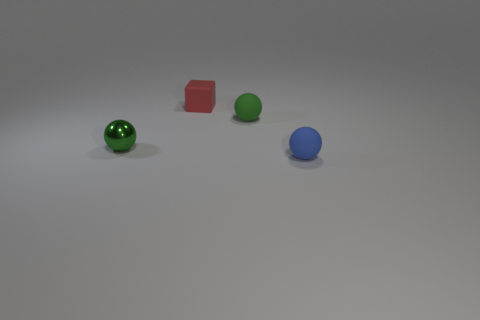Subtract all green balls. How many balls are left? 1 Add 2 big purple rubber things. How many objects exist? 6 Subtract all tiny matte spheres. How many spheres are left? 1 Add 1 small green rubber cylinders. How many small green rubber cylinders exist? 1 Subtract 1 red blocks. How many objects are left? 3 Subtract all spheres. How many objects are left? 1 Subtract 1 spheres. How many spheres are left? 2 Subtract all gray balls. Subtract all green cylinders. How many balls are left? 3 Subtract all cyan cylinders. How many green spheres are left? 2 Subtract all tiny green matte spheres. Subtract all small rubber blocks. How many objects are left? 2 